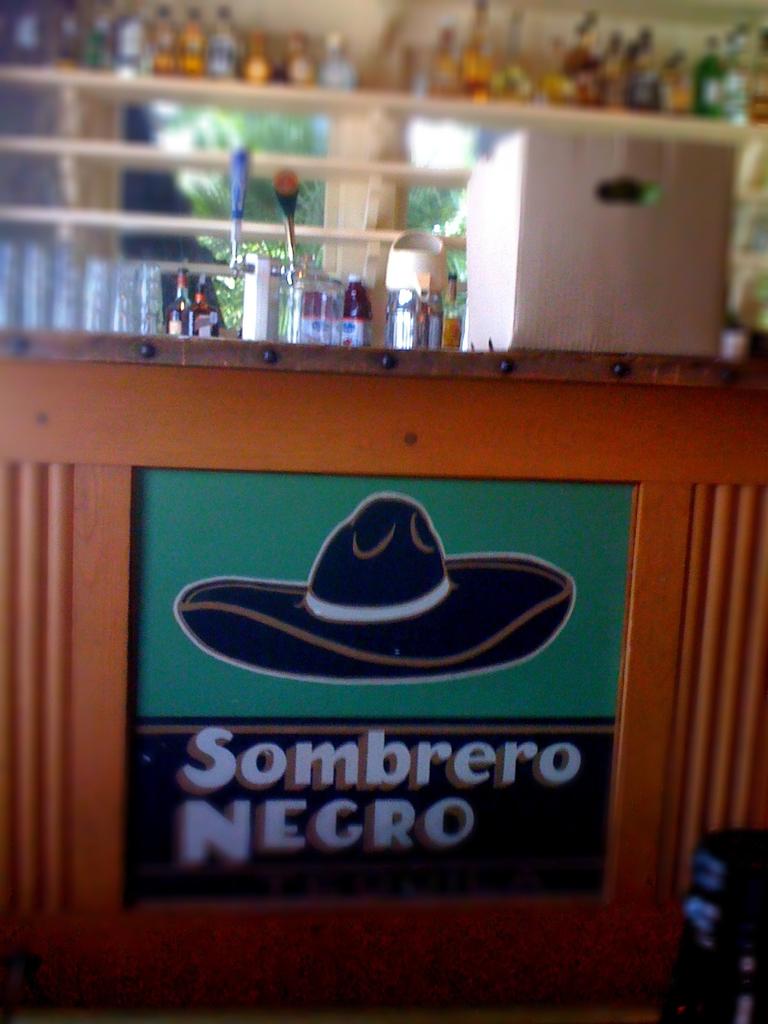Does this mean i need to wear a black hat?
Your response must be concise. Yes. What does the sign say?
Provide a succinct answer. Sombrero negro. 